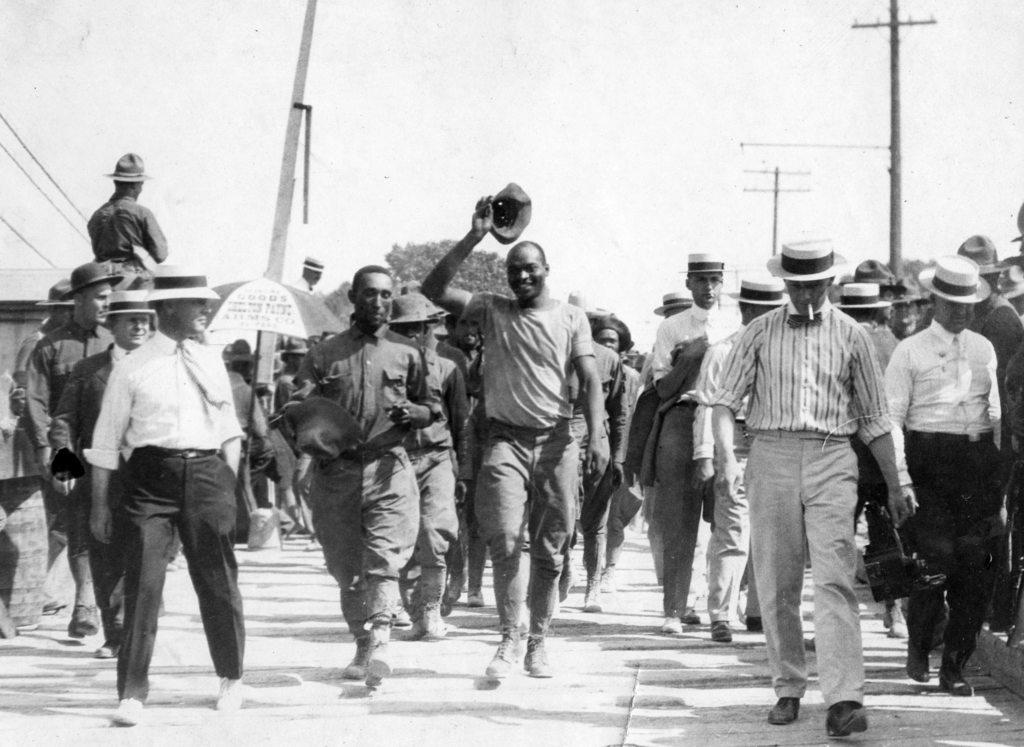What is the color scheme of the image? The image is black and white. Who or what can be seen in the image? There are people in the image. What object is present in the image that might provide shelter from the rain? There is an umbrella in the image. What type of information is displayed in the image? There are current polls in the image. What type of natural scenery is visible in the image? There are trees in the image. What part of the natural environment is visible in the image? The sky is visible in the image. What type of headwear is worn by some people in the image? Some people in the image are wearing hats. What type of marble is used to decorate the form in the image? There is no form or marble present in the image. What type of beef is being served at the event in the image? There is no event or beef present in the image. 